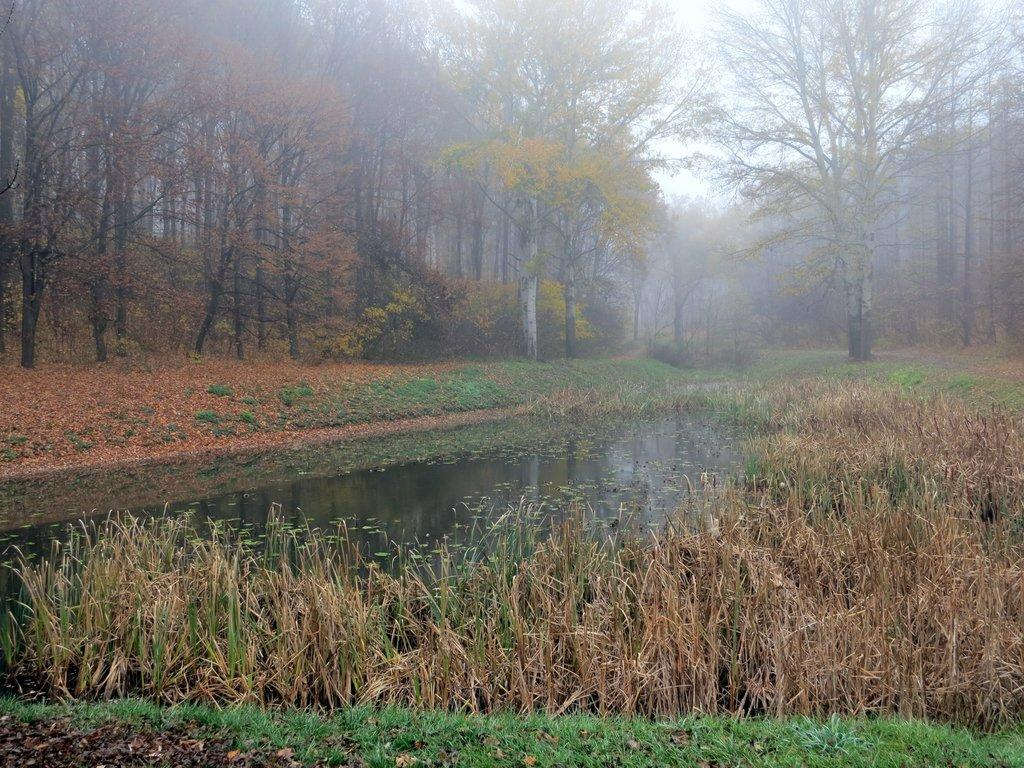What type of vegetation can be seen in the image? There is grass, plants, and trees in the image. What else is present in the image besides vegetation? There is water and the sky visible in the image. Can you describe the sky in the image? The sky is visible in the image. How many women are present in the image? There are no women present in the image; it features grass, plants, trees, water, and the sky. What type of emotion is expressed by the plants in the image? The plants in the image do not express emotions, as they are inanimate objects. 